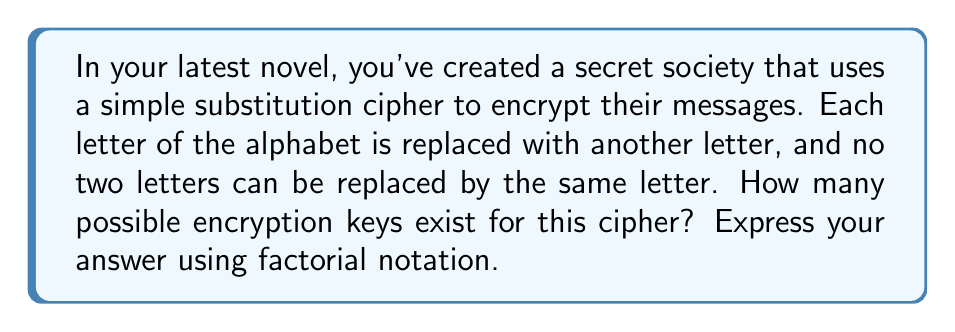Provide a solution to this math problem. Let's approach this step-by-step:

1) In a simple substitution cipher, each letter of the alphabet is replaced by another letter.

2) There are 26 letters in the English alphabet.

3) For the first letter, we have 26 choices.

4) For the second letter, we have 25 choices, as we can't use the letter we used for the first substitution.

5) For the third letter, we have 24 choices, and so on.

6) This pattern continues until we reach the last letter, for which we have only 1 choice left.

7) Mathematically, this can be expressed as:

   $$26 \times 25 \times 24 \times 23 \times ... \times 2 \times 1$$

8) This is the definition of 26 factorial, which is written as 26!

Therefore, the number of possible encryption keys for this simple substitution cipher is 26!.
Answer: 26! 